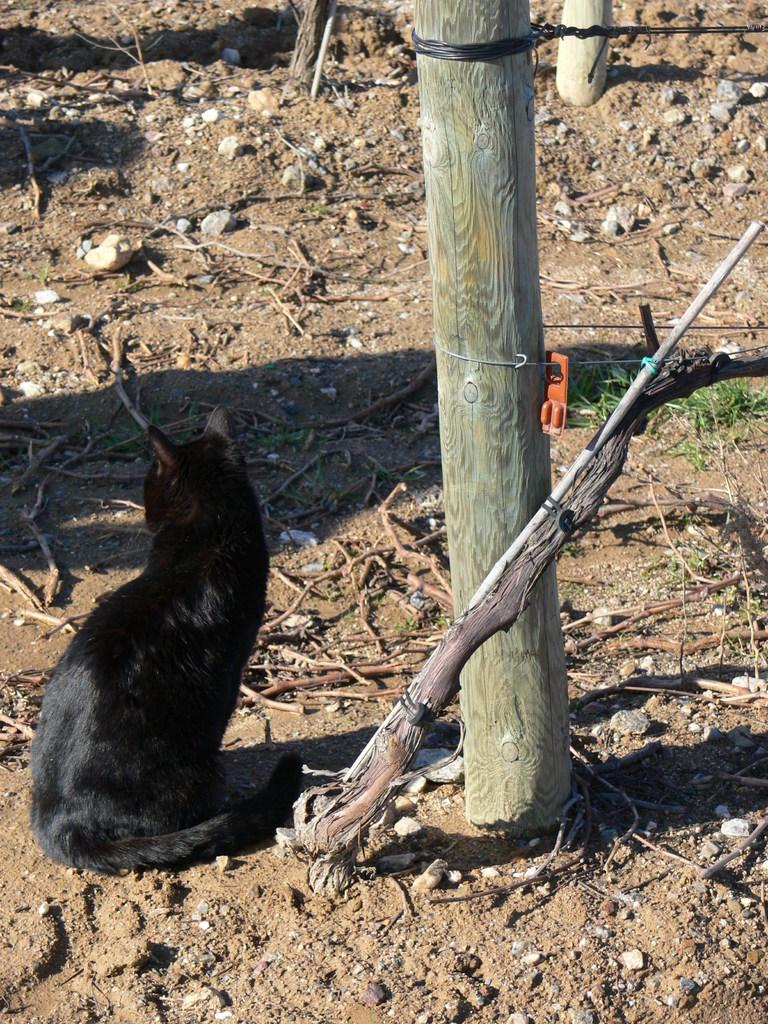What animal is sitting on the ground on the left side of the image? There is a cat sitting on the ground on the left side of the image. What can be seen in the background of the image? In the background of the image, there are logs, wires, stones, twigs, and sand. What type of finger can be seen holding the twigs in the image? There are no fingers visible in the image; only the cat, logs, wires, stones, twigs, and sand can be seen. 